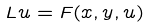<formula> <loc_0><loc_0><loc_500><loc_500>L u = F ( x , y , u )</formula> 